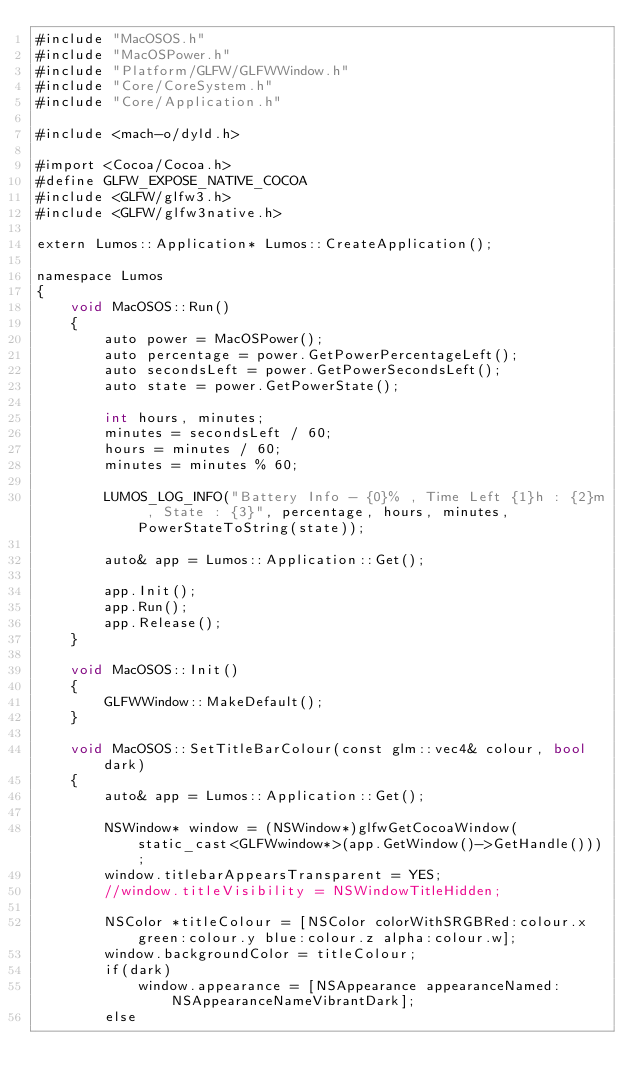<code> <loc_0><loc_0><loc_500><loc_500><_ObjectiveC_>#include "MacOSOS.h"
#include "MacOSPower.h"
#include "Platform/GLFW/GLFWWindow.h"
#include "Core/CoreSystem.h"
#include "Core/Application.h"

#include <mach-o/dyld.h>

#import <Cocoa/Cocoa.h>
#define GLFW_EXPOSE_NATIVE_COCOA
#include <GLFW/glfw3.h>
#include <GLFW/glfw3native.h>

extern Lumos::Application* Lumos::CreateApplication();

namespace Lumos
{
    void MacOSOS::Run()
    {
        auto power = MacOSPower();
        auto percentage = power.GetPowerPercentageLeft();
        auto secondsLeft = power.GetPowerSecondsLeft();
        auto state = power.GetPowerState();
		
		int hours, minutes;
		minutes = secondsLeft / 60;
		hours = minutes / 60;
		minutes = minutes % 60;
		
        LUMOS_LOG_INFO("Battery Info - {0}% , Time Left {1}h : {2}m , State : {3}", percentage, hours, minutes, PowerStateToString(state));

        auto& app = Lumos::Application::Get();

        app.Init();
        app.Run();
        app.Release();
    }

    void MacOSOS::Init()
    {
        GLFWWindow::MakeDefault();
    }

    void MacOSOS::SetTitleBarColour(const glm::vec4& colour, bool dark)
    {
        auto& app = Lumos::Application::Get();

        NSWindow* window = (NSWindow*)glfwGetCocoaWindow(static_cast<GLFWwindow*>(app.GetWindow()->GetHandle()));
        window.titlebarAppearsTransparent = YES;
        //window.titleVisibility = NSWindowTitleHidden;
        
        NSColor *titleColour = [NSColor colorWithSRGBRed:colour.x green:colour.y blue:colour.z alpha:colour.w];
        window.backgroundColor = titleColour;
        if(dark)
            window.appearance = [NSAppearance appearanceNamed:NSAppearanceNameVibrantDark];
        else</code> 